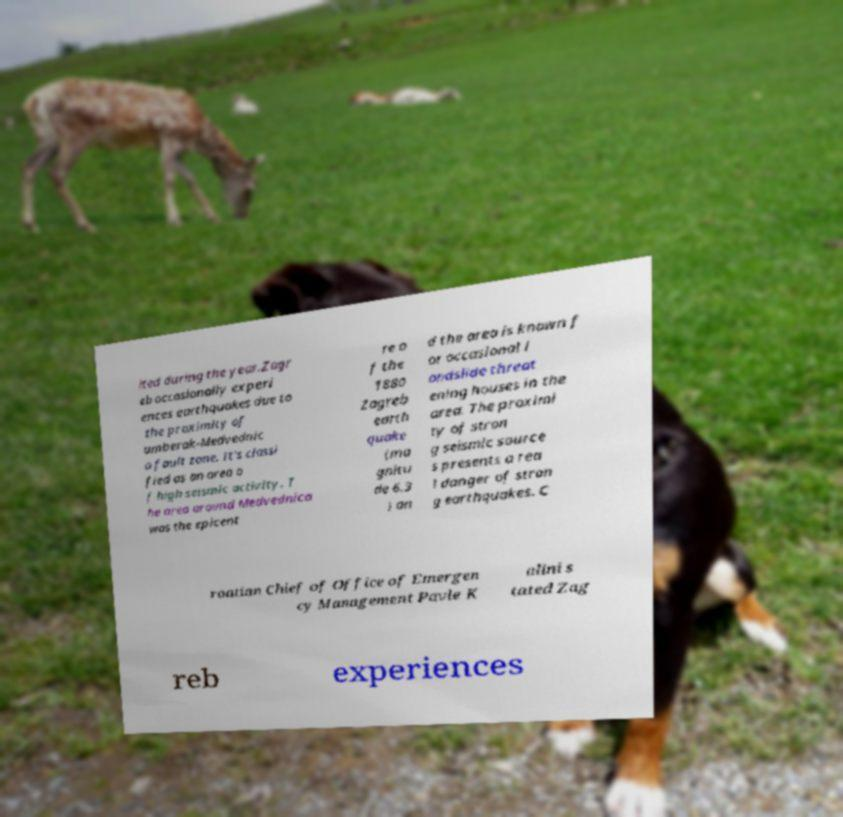For documentation purposes, I need the text within this image transcribed. Could you provide that? ited during the year.Zagr eb occasionally experi ences earthquakes due to the proximity of umberak-Medvednic a fault zone. It's classi fied as an area o f high seismic activity. T he area around Medvednica was the epicent re o f the 1880 Zagreb earth quake (ma gnitu de 6.3 ) an d the area is known f or occasional l andslide threat ening houses in the area. The proximi ty of stron g seismic source s presents a rea l danger of stron g earthquakes. C roatian Chief of Office of Emergen cy Management Pavle K alini s tated Zag reb experiences 